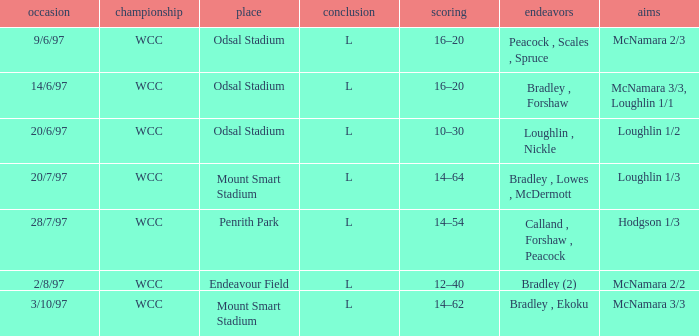What were the goals on 3/10/97? McNamara 3/3. 